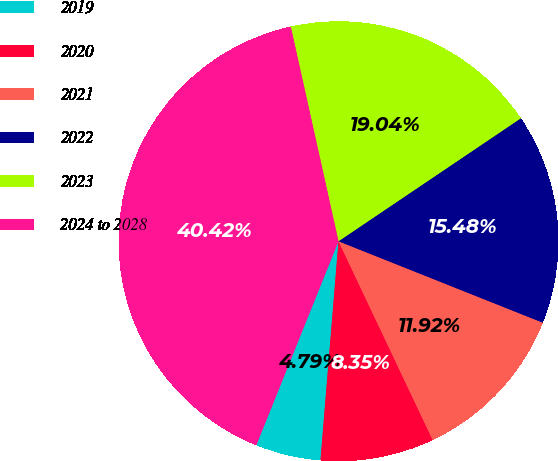<chart> <loc_0><loc_0><loc_500><loc_500><pie_chart><fcel>2019<fcel>2020<fcel>2021<fcel>2022<fcel>2023<fcel>2024 to 2028<nl><fcel>4.79%<fcel>8.35%<fcel>11.92%<fcel>15.48%<fcel>19.04%<fcel>40.42%<nl></chart> 